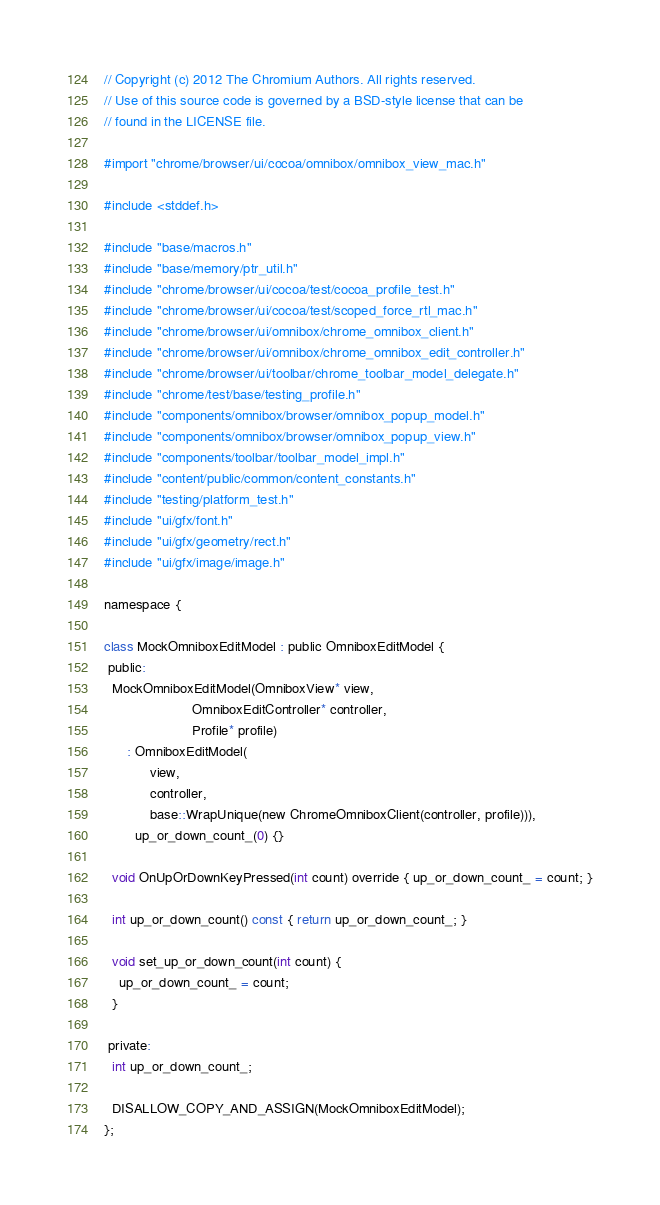<code> <loc_0><loc_0><loc_500><loc_500><_ObjectiveC_>// Copyright (c) 2012 The Chromium Authors. All rights reserved.
// Use of this source code is governed by a BSD-style license that can be
// found in the LICENSE file.

#import "chrome/browser/ui/cocoa/omnibox/omnibox_view_mac.h"

#include <stddef.h>

#include "base/macros.h"
#include "base/memory/ptr_util.h"
#include "chrome/browser/ui/cocoa/test/cocoa_profile_test.h"
#include "chrome/browser/ui/cocoa/test/scoped_force_rtl_mac.h"
#include "chrome/browser/ui/omnibox/chrome_omnibox_client.h"
#include "chrome/browser/ui/omnibox/chrome_omnibox_edit_controller.h"
#include "chrome/browser/ui/toolbar/chrome_toolbar_model_delegate.h"
#include "chrome/test/base/testing_profile.h"
#include "components/omnibox/browser/omnibox_popup_model.h"
#include "components/omnibox/browser/omnibox_popup_view.h"
#include "components/toolbar/toolbar_model_impl.h"
#include "content/public/common/content_constants.h"
#include "testing/platform_test.h"
#include "ui/gfx/font.h"
#include "ui/gfx/geometry/rect.h"
#include "ui/gfx/image/image.h"

namespace {

class MockOmniboxEditModel : public OmniboxEditModel {
 public:
  MockOmniboxEditModel(OmniboxView* view,
                       OmniboxEditController* controller,
                       Profile* profile)
      : OmniboxEditModel(
            view,
            controller,
            base::WrapUnique(new ChromeOmniboxClient(controller, profile))),
        up_or_down_count_(0) {}

  void OnUpOrDownKeyPressed(int count) override { up_or_down_count_ = count; }

  int up_or_down_count() const { return up_or_down_count_; }

  void set_up_or_down_count(int count) {
    up_or_down_count_ = count;
  }

 private:
  int up_or_down_count_;

  DISALLOW_COPY_AND_ASSIGN(MockOmniboxEditModel);
};
</code> 